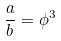Convert formula to latex. <formula><loc_0><loc_0><loc_500><loc_500>\frac { a } { b } = \phi ^ { 3 }</formula> 